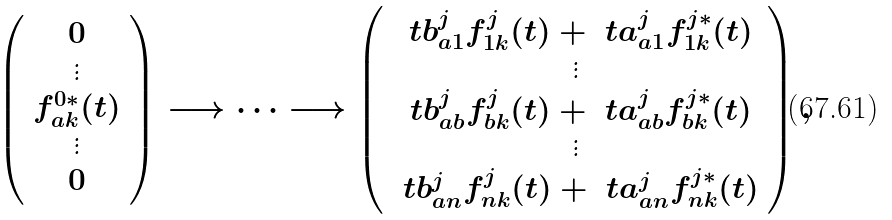Convert formula to latex. <formula><loc_0><loc_0><loc_500><loc_500>\left ( \begin{array} { c } 0 \\ \vdots \\ f _ { a k } ^ { 0 * } ( t ) \\ \vdots \\ 0 \end{array} \right ) \longrightarrow \cdots \longrightarrow \left ( \begin{array} { c } \ t b _ { a 1 } ^ { j } f _ { 1 k } ^ { j } ( t ) + \ t a _ { a 1 } ^ { j } f _ { 1 k } ^ { j * } ( t ) \\ \vdots \\ \ t b _ { a b } ^ { j } f _ { b k } ^ { j } ( t ) + \ t a _ { a b } ^ { j } f _ { b k } ^ { j * } ( t ) \\ \vdots \\ \ t b _ { a n } ^ { j } f _ { n k } ^ { j } ( t ) + \ t a _ { a n } ^ { j } f _ { n k } ^ { j * } ( t ) \end{array} \right ) ,</formula> 